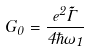<formula> <loc_0><loc_0><loc_500><loc_500>G _ { 0 } = \frac { e ^ { 2 } \tilde { \Gamma } } { 4 \hbar { \omega } _ { 1 } }</formula> 